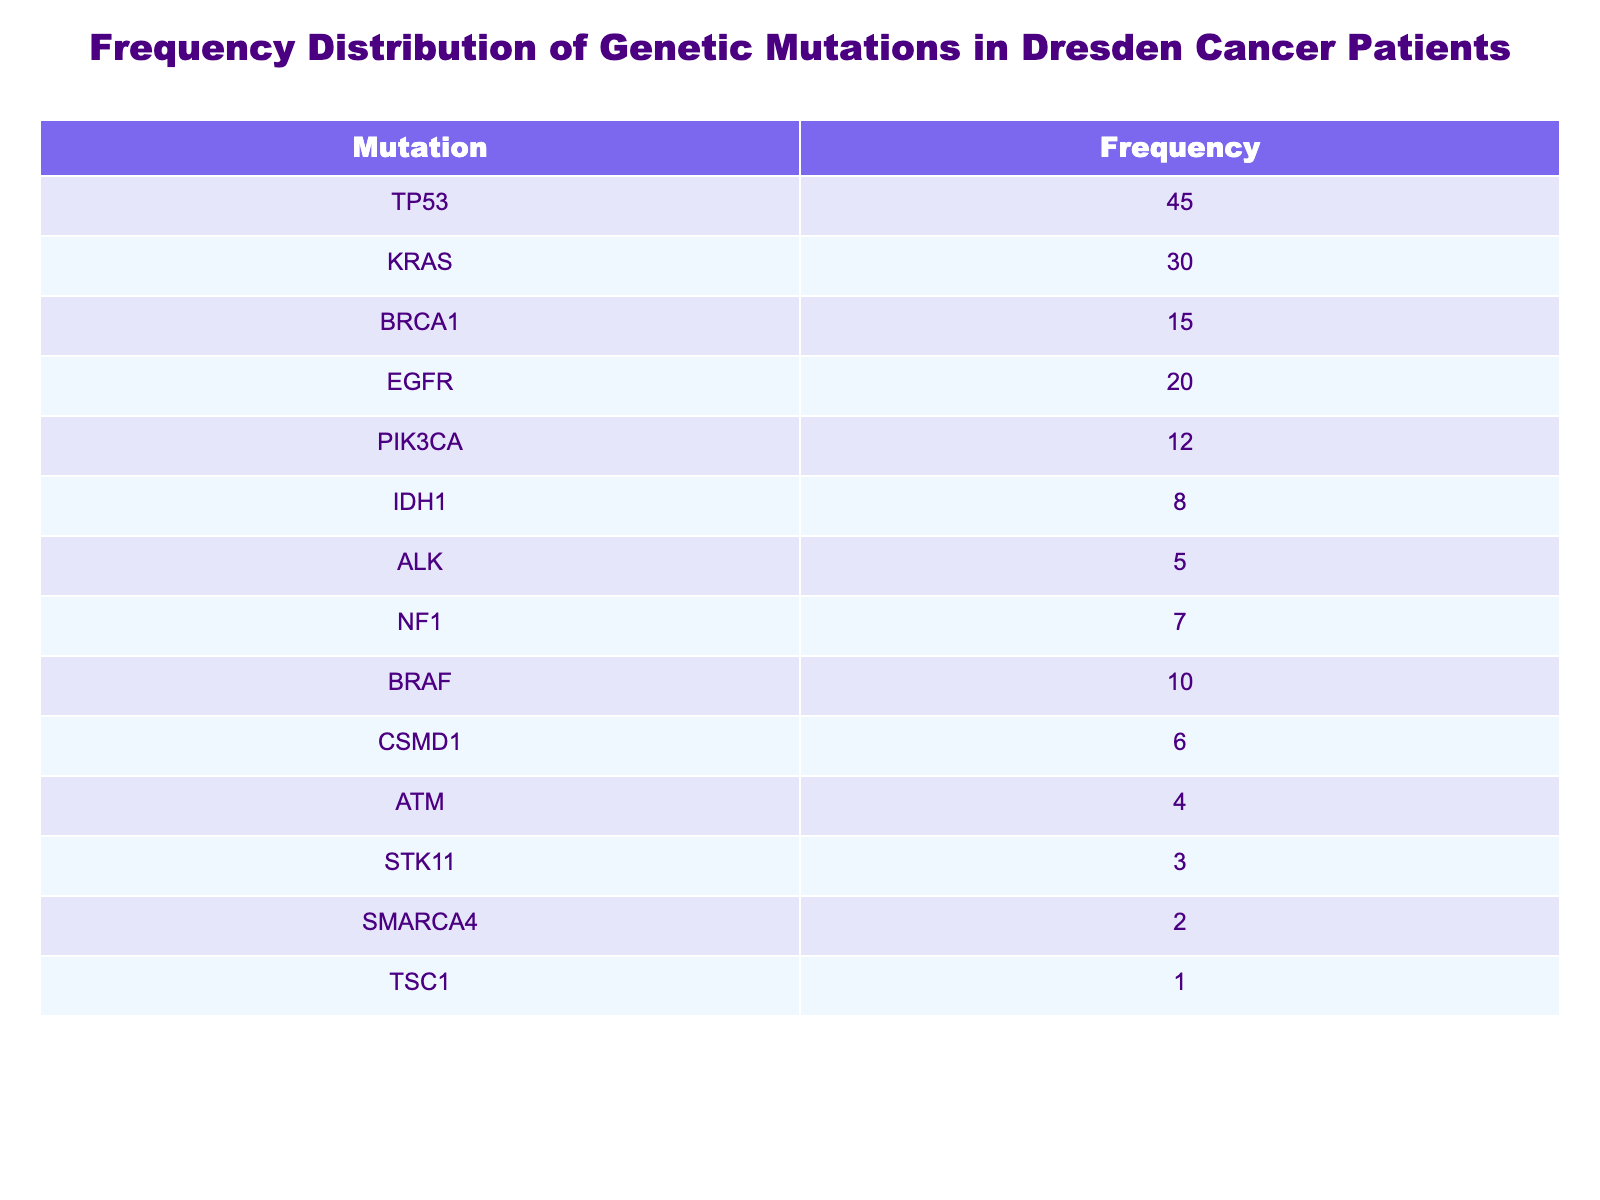What is the frequency of the TP53 mutation? The frequency of the TP53 mutation is directly listed in the table under the "Frequency" column. It shows a frequency of 45.
Answer: 45 How many patients in total have the KRAS and BRCA1 mutations combined? To find this, add the frequencies of the KRAS (30) and BRCA1 (15) mutations together: 30 + 15 = 45.
Answer: 45 Is the frequency of the BRAF mutation greater than the frequency of the NF1 mutation? The table lists the frequency of BRAF as 10 and NF1 as 7. Since 10 is greater than 7, the statement is true.
Answer: Yes What is the average frequency of the mutations listed in the table? First, sum the frequencies of all mutations: 45 + 30 + 15 + 20 + 12 + 8 + 5 + 7 + 10 + 6 + 4 + 3 + 2 + 1 = 163. There are 14 mutations, so divide the total by 14: 163 / 14 ≈ 11.64.
Answer: 11.64 How many mutations have a frequency of 10 or less? The mutations with a frequency of 10 or less are PIK3CA (12), IDH1 (8), ALK (5), NF1 (7), BRAF (10), CSMD1 (6), ATM (4), STK11 (3), SMARCA4 (2), and TSC1 (1), which totals to 6 mutations.
Answer: 6 What is the difference in frequency between the most and least prevalent mutations? The most prevalent mutation is TP53 with a frequency of 45, and the least prevalent is TSC1 with a frequency of 1. The difference is 45 - 1 = 44.
Answer: 44 Is there a mutation with a frequency of 2? By checking the table, we can see that SMARCA4 has a frequency of 2. Thus, the answer is yes.
Answer: Yes What is the total frequency of mutations associated with lung cancer (EGFR, KRAS, ALK)? The associated mutations are: EGFR (20), KRAS (30), and ALK (5). Adding these gives: 20 + 30 + 5 = 55.
Answer: 55 How many mutations have a frequency greater than 25? The mutations with a frequency greater than 25 are TP53 (45), KRAS (30), and one additional mutation, yielding a total of 2 mutations.
Answer: 2 